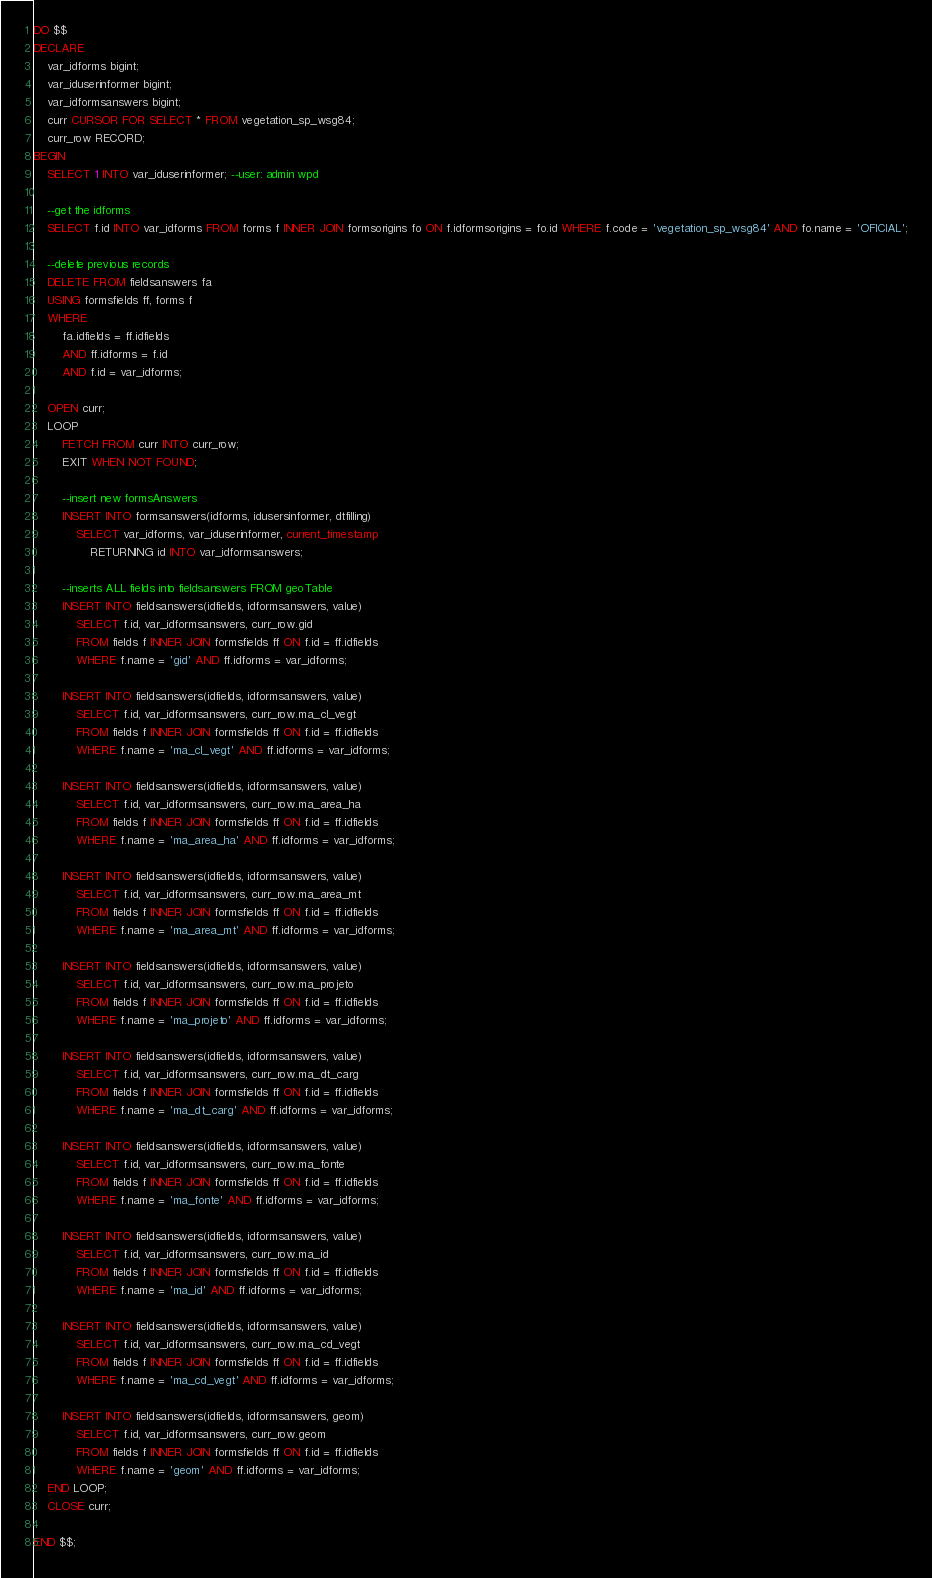Convert code to text. <code><loc_0><loc_0><loc_500><loc_500><_SQL_>DO $$
DECLARE 
    var_idforms bigint;
    var_iduserinformer bigint;
    var_idformsanswers bigint;
    curr CURSOR FOR SELECT * FROM vegetation_sp_wsg84;
    curr_row RECORD;
BEGIN
    SELECT 1 INTO var_iduserinformer; --user: admin wpd

    --get the idforms
    SELECT f.id INTO var_idforms FROM forms f INNER JOIN formsorigins fo ON f.idformsorigins = fo.id WHERE f.code = 'vegetation_sp_wsg84' AND fo.name = 'OFICIAL';

    --delete previous records
    DELETE FROM fieldsanswers fa 
    USING formsfields ff, forms f
    WHERE 
        fa.idfields = ff.idfields
        AND ff.idforms = f.id 
        AND f.id = var_idforms;

    OPEN curr;
    LOOP
        FETCH FROM curr INTO curr_row;
        EXIT WHEN NOT FOUND;

        --insert new formsAnswers
        INSERT INTO formsanswers(idforms, idusersinformer, dtfilling)
            SELECT var_idforms, var_iduserinformer, current_timestamp
                RETURNING id INTO var_idformsanswers;

        --inserts ALL fields into fieldsanswers FROM geoTable
        INSERT INTO fieldsanswers(idfields, idformsanswers, value) 
            SELECT f.id, var_idformsanswers, curr_row.gid 
            FROM fields f INNER JOIN formsfields ff ON f.id = ff.idfields 
            WHERE f.name = 'gid' AND ff.idforms = var_idforms;

        INSERT INTO fieldsanswers(idfields, idformsanswers, value) 
            SELECT f.id, var_idformsanswers, curr_row.ma_cl_vegt 
            FROM fields f INNER JOIN formsfields ff ON f.id = ff.idfields 
            WHERE f.name = 'ma_cl_vegt' AND ff.idforms = var_idforms;

        INSERT INTO fieldsanswers(idfields, idformsanswers, value) 
            SELECT f.id, var_idformsanswers, curr_row.ma_area_ha 
            FROM fields f INNER JOIN formsfields ff ON f.id = ff.idfields 
            WHERE f.name = 'ma_area_ha' AND ff.idforms = var_idforms;

        INSERT INTO fieldsanswers(idfields, idformsanswers, value) 
            SELECT f.id, var_idformsanswers, curr_row.ma_area_mt 
            FROM fields f INNER JOIN formsfields ff ON f.id = ff.idfields 
            WHERE f.name = 'ma_area_mt' AND ff.idforms = var_idforms;

        INSERT INTO fieldsanswers(idfields, idformsanswers, value) 
            SELECT f.id, var_idformsanswers, curr_row.ma_projeto 
            FROM fields f INNER JOIN formsfields ff ON f.id = ff.idfields 
            WHERE f.name = 'ma_projeto' AND ff.idforms = var_idforms;

        INSERT INTO fieldsanswers(idfields, idformsanswers, value) 
            SELECT f.id, var_idformsanswers, curr_row.ma_dt_carg 
            FROM fields f INNER JOIN formsfields ff ON f.id = ff.idfields 
            WHERE f.name = 'ma_dt_carg' AND ff.idforms = var_idforms;

        INSERT INTO fieldsanswers(idfields, idformsanswers, value) 
            SELECT f.id, var_idformsanswers, curr_row.ma_fonte 
            FROM fields f INNER JOIN formsfields ff ON f.id = ff.idfields 
            WHERE f.name = 'ma_fonte' AND ff.idforms = var_idforms;

        INSERT INTO fieldsanswers(idfields, idformsanswers, value) 
            SELECT f.id, var_idformsanswers, curr_row.ma_id 
            FROM fields f INNER JOIN formsfields ff ON f.id = ff.idfields 
            WHERE f.name = 'ma_id' AND ff.idforms = var_idforms;

        INSERT INTO fieldsanswers(idfields, idformsanswers, value) 
            SELECT f.id, var_idformsanswers, curr_row.ma_cd_vegt 
            FROM fields f INNER JOIN formsfields ff ON f.id = ff.idfields 
            WHERE f.name = 'ma_cd_vegt' AND ff.idforms = var_idforms;

        INSERT INTO fieldsanswers(idfields, idformsanswers, geom) 
            SELECT f.id, var_idformsanswers, curr_row.geom 
            FROM fields f INNER JOIN formsfields ff ON f.id = ff.idfields 
            WHERE f.name = 'geom' AND ff.idforms = var_idforms;
    END LOOP;
    CLOSE curr;          

END $$;
</code> 